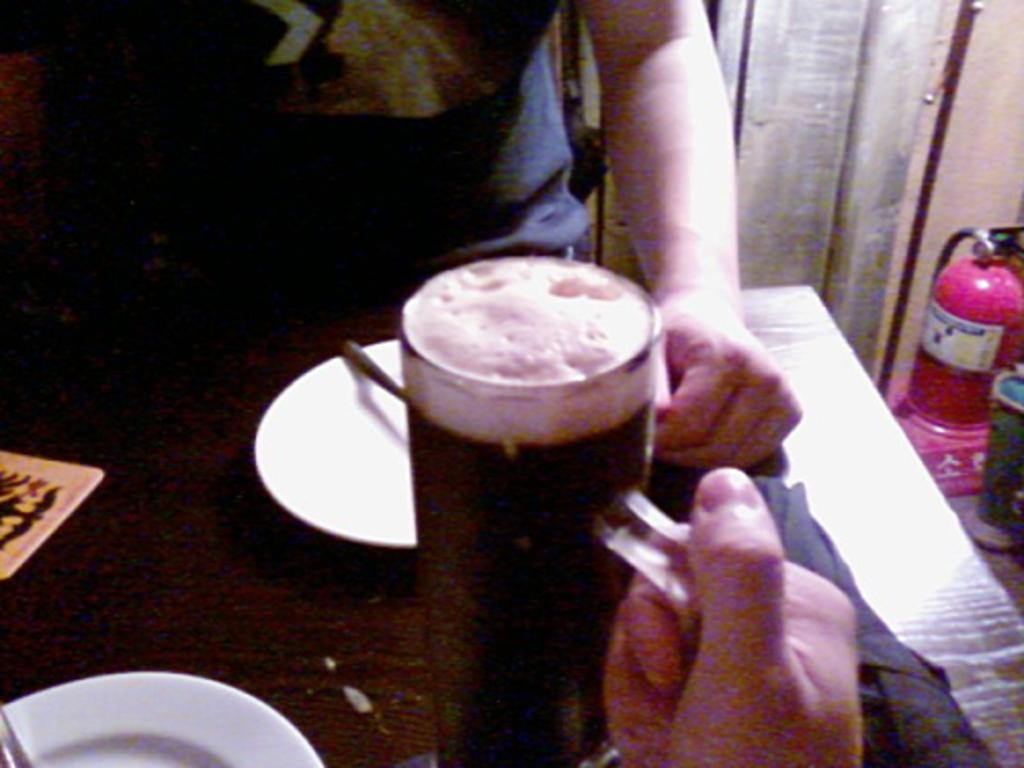Describe this image in one or two sentences. In this image I can see a brown colored table and on the table I can see two plates which are white in color, a glass and I can see a person sitting on a chair in front of a table and a person's hand holding a table. To the right side of the image I can see few other objects which are pink and green in color. 